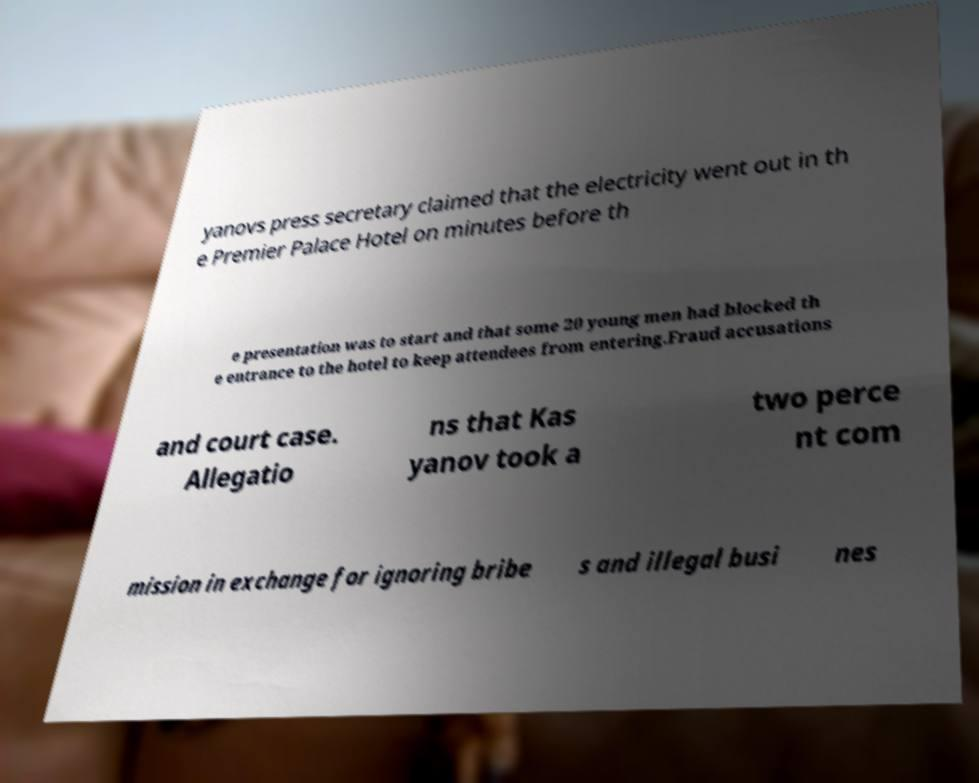For documentation purposes, I need the text within this image transcribed. Could you provide that? yanovs press secretary claimed that the electricity went out in th e Premier Palace Hotel on minutes before th e presentation was to start and that some 20 young men had blocked th e entrance to the hotel to keep attendees from entering.Fraud accusations and court case. Allegatio ns that Kas yanov took a two perce nt com mission in exchange for ignoring bribe s and illegal busi nes 